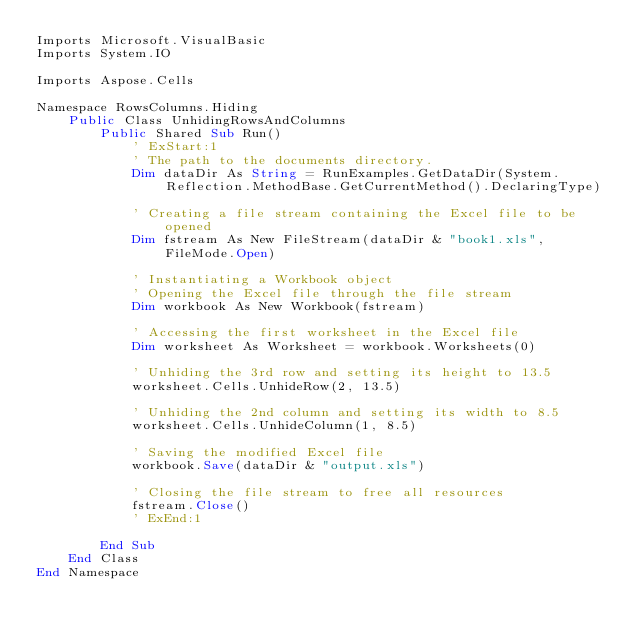<code> <loc_0><loc_0><loc_500><loc_500><_VisualBasic_>Imports Microsoft.VisualBasic
Imports System.IO

Imports Aspose.Cells

Namespace RowsColumns.Hiding
    Public Class UnhidingRowsAndColumns
        Public Shared Sub Run()
            ' ExStart:1
            ' The path to the documents directory.
            Dim dataDir As String = RunExamples.GetDataDir(System.Reflection.MethodBase.GetCurrentMethod().DeclaringType)

            ' Creating a file stream containing the Excel file to be opened
            Dim fstream As New FileStream(dataDir & "book1.xls", FileMode.Open)

            ' Instantiating a Workbook object
            ' Opening the Excel file through the file stream
            Dim workbook As New Workbook(fstream)

            ' Accessing the first worksheet in the Excel file
            Dim worksheet As Worksheet = workbook.Worksheets(0)

            ' Unhiding the 3rd row and setting its height to 13.5
            worksheet.Cells.UnhideRow(2, 13.5)

            ' Unhiding the 2nd column and setting its width to 8.5
            worksheet.Cells.UnhideColumn(1, 8.5)

            ' Saving the modified Excel file
            workbook.Save(dataDir & "output.xls")

            ' Closing the file stream to free all resources
            fstream.Close()
            ' ExEnd:1

        End Sub
    End Class
End Namespace</code> 